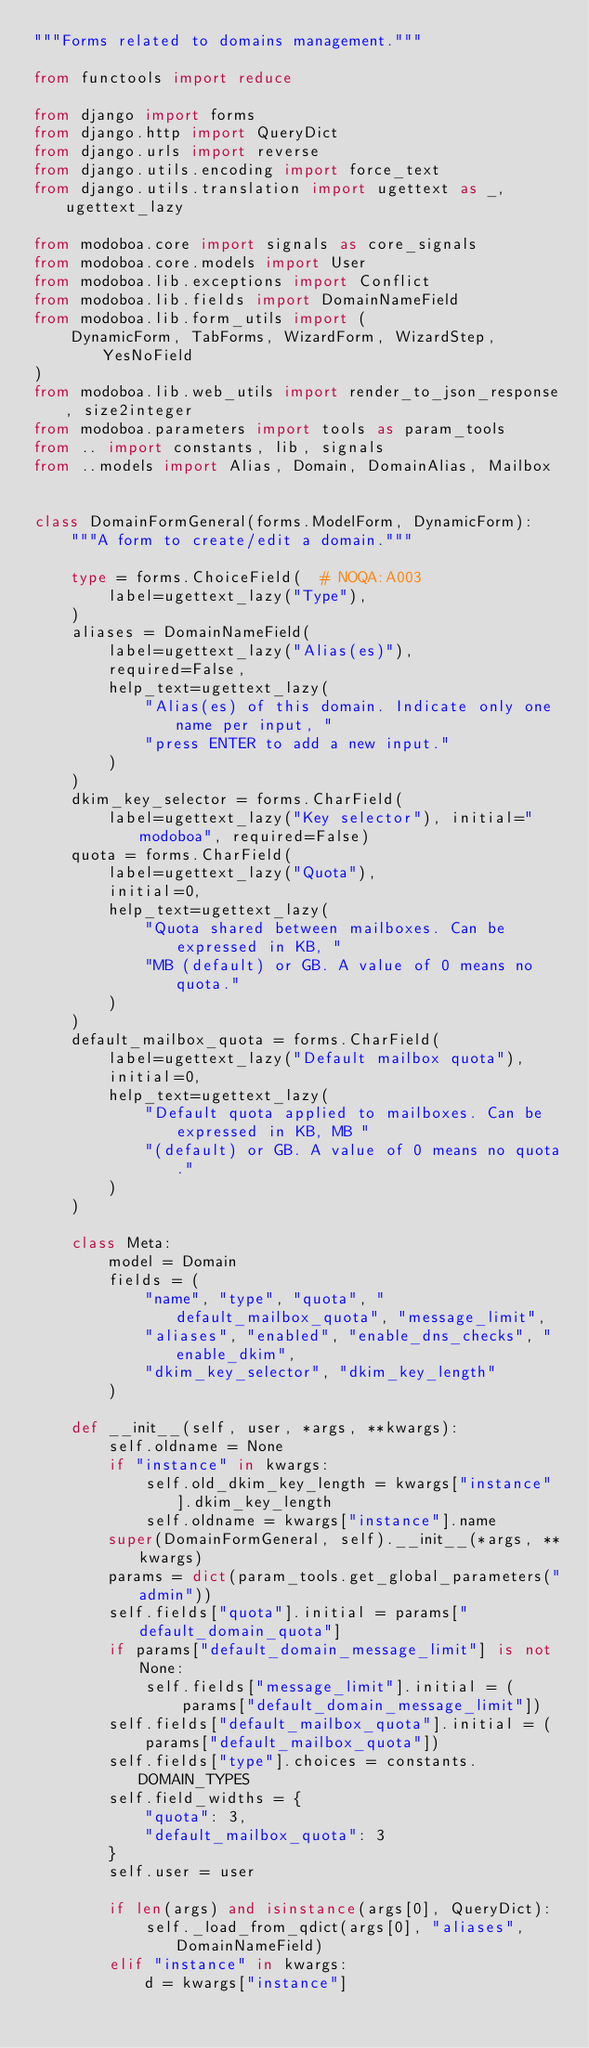<code> <loc_0><loc_0><loc_500><loc_500><_Python_>"""Forms related to domains management."""

from functools import reduce

from django import forms
from django.http import QueryDict
from django.urls import reverse
from django.utils.encoding import force_text
from django.utils.translation import ugettext as _, ugettext_lazy

from modoboa.core import signals as core_signals
from modoboa.core.models import User
from modoboa.lib.exceptions import Conflict
from modoboa.lib.fields import DomainNameField
from modoboa.lib.form_utils import (
    DynamicForm, TabForms, WizardForm, WizardStep, YesNoField
)
from modoboa.lib.web_utils import render_to_json_response, size2integer
from modoboa.parameters import tools as param_tools
from .. import constants, lib, signals
from ..models import Alias, Domain, DomainAlias, Mailbox


class DomainFormGeneral(forms.ModelForm, DynamicForm):
    """A form to create/edit a domain."""

    type = forms.ChoiceField(  # NOQA:A003
        label=ugettext_lazy("Type"),
    )
    aliases = DomainNameField(
        label=ugettext_lazy("Alias(es)"),
        required=False,
        help_text=ugettext_lazy(
            "Alias(es) of this domain. Indicate only one name per input, "
            "press ENTER to add a new input."
        )
    )
    dkim_key_selector = forms.CharField(
        label=ugettext_lazy("Key selector"), initial="modoboa", required=False)
    quota = forms.CharField(
        label=ugettext_lazy("Quota"),
        initial=0,
        help_text=ugettext_lazy(
            "Quota shared between mailboxes. Can be expressed in KB, "
            "MB (default) or GB. A value of 0 means no quota."
        )
    )
    default_mailbox_quota = forms.CharField(
        label=ugettext_lazy("Default mailbox quota"),
        initial=0,
        help_text=ugettext_lazy(
            "Default quota applied to mailboxes. Can be expressed in KB, MB "
            "(default) or GB. A value of 0 means no quota."
        )
    )

    class Meta:
        model = Domain
        fields = (
            "name", "type", "quota", "default_mailbox_quota", "message_limit",
            "aliases", "enabled", "enable_dns_checks", "enable_dkim",
            "dkim_key_selector", "dkim_key_length"
        )

    def __init__(self, user, *args, **kwargs):
        self.oldname = None
        if "instance" in kwargs:
            self.old_dkim_key_length = kwargs["instance"].dkim_key_length
            self.oldname = kwargs["instance"].name
        super(DomainFormGeneral, self).__init__(*args, **kwargs)
        params = dict(param_tools.get_global_parameters("admin"))
        self.fields["quota"].initial = params["default_domain_quota"]
        if params["default_domain_message_limit"] is not None:
            self.fields["message_limit"].initial = (
                params["default_domain_message_limit"])
        self.fields["default_mailbox_quota"].initial = (
            params["default_mailbox_quota"])
        self.fields["type"].choices = constants.DOMAIN_TYPES
        self.field_widths = {
            "quota": 3,
            "default_mailbox_quota": 3
        }
        self.user = user

        if len(args) and isinstance(args[0], QueryDict):
            self._load_from_qdict(args[0], "aliases", DomainNameField)
        elif "instance" in kwargs:
            d = kwargs["instance"]</code> 